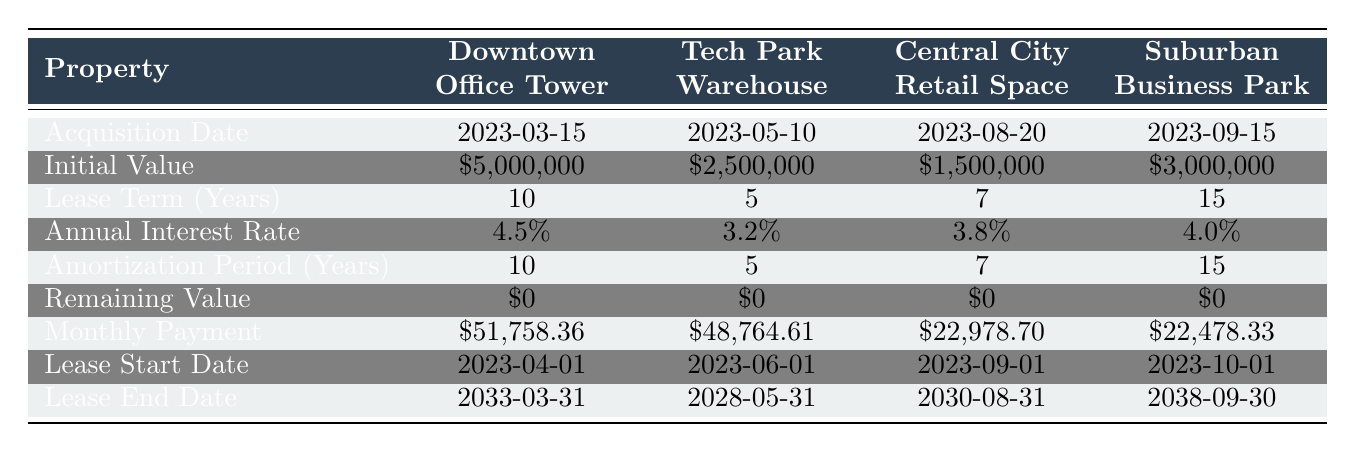What is the initial value of the Downtown Office Tower? The initial value is given directly in the table for the Downtown Office Tower, which shows \$5,000,000.
Answer: 5,000,000 What is the annual interest rate for the Tech Park Warehouse? The table indicates that the annual interest rate for the Tech Park Warehouse is 3.2%.
Answer: 3.2% How long is the lease term for the Central City Retail Space? The lease term for the Central City Retail Space is stated as 7 years in the table.
Answer: 7 years What is the total initial value of all lease obligations? The initial values can be summed: 5,000,000 + 2,500,000 + 1,500,000 + 3,000,000 = 12,000,000. Thus, the total initial value of all lease obligations is \$12,000,000.
Answer: 12,000,000 Is the remaining value for the Suburban Business Park zero? The table shows that the remaining value for the Suburban Business Park is \$0. Therefore, the statement is true.
Answer: Yes Which property has the highest monthly payment? By comparing the monthly payments listed in the table: Downtown Office Tower at 51,758.36, Tech Park Warehouse at 48,764.61, Central City Retail Space at 22,978.70, and Suburban Business Park at 22,478.33, the Downtown Office Tower has the highest monthly payment.
Answer: Downtown Office Tower What is the average annual interest rate across all properties? The average can be calculated by summing the annual interest rates: (4.5 + 3.2 + 3.8 + 4.0) / 4 = 3.625%. Therefore, the average annual interest rate is 3.625%.
Answer: 3.625% How many properties have a lease term greater than 7 years? From the table, Downtown Office Tower (10 years) and Suburban Business Park (15 years) have lease terms greater than 7 years. Thus, there are 2 properties with lease terms greater than 7 years.
Answer: 2 Which property was acquired last, and when? The property with the latest acquisition date in the table is the Suburban Business Park, acquired on 2023-09-15.
Answer: Suburban Business Park, 2023-09-15 